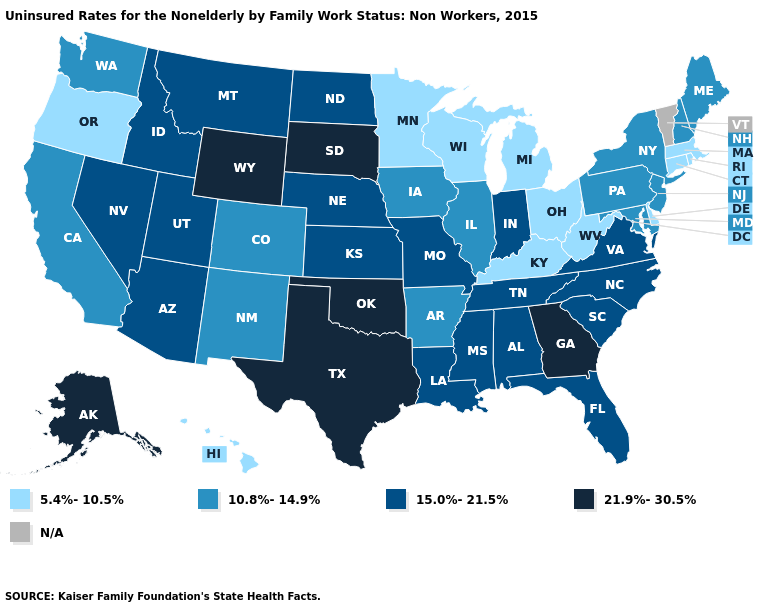What is the value of Ohio?
Quick response, please. 5.4%-10.5%. Which states have the lowest value in the USA?
Quick response, please. Connecticut, Delaware, Hawaii, Kentucky, Massachusetts, Michigan, Minnesota, Ohio, Oregon, Rhode Island, West Virginia, Wisconsin. Name the states that have a value in the range 10.8%-14.9%?
Write a very short answer. Arkansas, California, Colorado, Illinois, Iowa, Maine, Maryland, New Hampshire, New Jersey, New Mexico, New York, Pennsylvania, Washington. Does the first symbol in the legend represent the smallest category?
Write a very short answer. Yes. Among the states that border Texas , which have the highest value?
Short answer required. Oklahoma. Among the states that border Colorado , which have the lowest value?
Short answer required. New Mexico. Name the states that have a value in the range 10.8%-14.9%?
Quick response, please. Arkansas, California, Colorado, Illinois, Iowa, Maine, Maryland, New Hampshire, New Jersey, New Mexico, New York, Pennsylvania, Washington. What is the lowest value in the West?
Answer briefly. 5.4%-10.5%. What is the lowest value in states that border Iowa?
Give a very brief answer. 5.4%-10.5%. Does Ohio have the lowest value in the MidWest?
Write a very short answer. Yes. Does Utah have the lowest value in the USA?
Keep it brief. No. Is the legend a continuous bar?
Concise answer only. No. Among the states that border Iowa , does Nebraska have the highest value?
Keep it brief. No. 